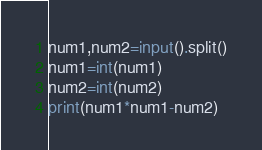Convert code to text. <code><loc_0><loc_0><loc_500><loc_500><_Python_>num1,num2=input().split()
num1=int(num1)
num2=int(num2)
print(num1*num1-num2)</code> 